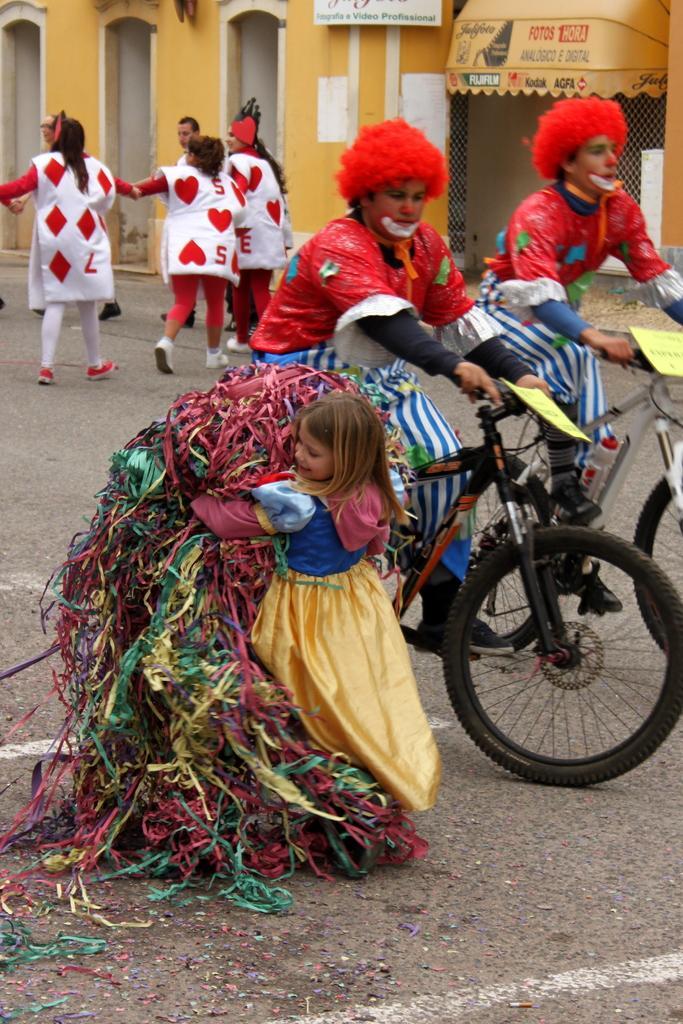Could you give a brief overview of what you see in this image? In this image I can see road and on it I can see few people are standing. I can also see two people are sitting on their bicycles. I can see all of them are wearing costumes. Here I can see a girl is holding few things. I can also see white lines on road, few yellow papers on cycles and in the background I can see a building. I can also see something is written over there. 